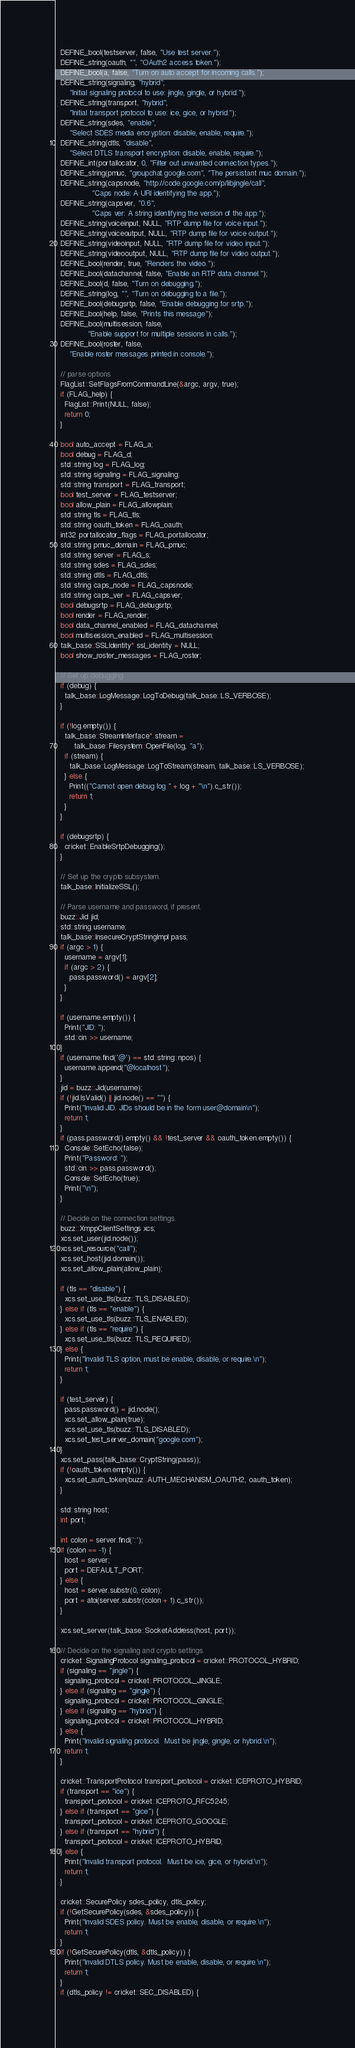<code> <loc_0><loc_0><loc_500><loc_500><_C++_>  DEFINE_bool(testserver, false, "Use test server.");
  DEFINE_string(oauth, "", "OAuth2 access token.");
  DEFINE_bool(a, false, "Turn on auto accept for incoming calls.");
  DEFINE_string(signaling, "hybrid",
      "Initial signaling protocol to use: jingle, gingle, or hybrid.");
  DEFINE_string(transport, "hybrid",
      "Initial transport protocol to use: ice, gice, or hybrid.");
  DEFINE_string(sdes, "enable",
      "Select SDES media encryption: disable, enable, require.");
  DEFINE_string(dtls, "disable",
      "Select DTLS transport encryption: disable, enable, require.");
  DEFINE_int(portallocator, 0, "Filter out unwanted connection types.");
  DEFINE_string(pmuc, "groupchat.google.com", "The persistant muc domain.");
  DEFINE_string(capsnode, "http://code.google.com/p/libjingle/call",
                "Caps node: A URI identifying the app.");
  DEFINE_string(capsver, "0.6",
                "Caps ver: A string identifying the version of the app.");
  DEFINE_string(voiceinput, NULL, "RTP dump file for voice input.");
  DEFINE_string(voiceoutput, NULL, "RTP dump file for voice output.");
  DEFINE_string(videoinput, NULL, "RTP dump file for video input.");
  DEFINE_string(videooutput, NULL, "RTP dump file for video output.");
  DEFINE_bool(render, true, "Renders the video.");
  DEFINE_bool(datachannel, false, "Enable an RTP data channel.");
  DEFINE_bool(d, false, "Turn on debugging.");
  DEFINE_string(log, "", "Turn on debugging to a file.");
  DEFINE_bool(debugsrtp, false, "Enable debugging for srtp.");
  DEFINE_bool(help, false, "Prints this message");
  DEFINE_bool(multisession, false,
              "Enable support for multiple sessions in calls.");
  DEFINE_bool(roster, false,
      "Enable roster messages printed in console.");

  // parse options
  FlagList::SetFlagsFromCommandLine(&argc, argv, true);
  if (FLAG_help) {
    FlagList::Print(NULL, false);
    return 0;
  }

  bool auto_accept = FLAG_a;
  bool debug = FLAG_d;
  std::string log = FLAG_log;
  std::string signaling = FLAG_signaling;
  std::string transport = FLAG_transport;
  bool test_server = FLAG_testserver;
  bool allow_plain = FLAG_allowplain;
  std::string tls = FLAG_tls;
  std::string oauth_token = FLAG_oauth;
  int32 portallocator_flags = FLAG_portallocator;
  std::string pmuc_domain = FLAG_pmuc;
  std::string server = FLAG_s;
  std::string sdes = FLAG_sdes;
  std::string dtls = FLAG_dtls;
  std::string caps_node = FLAG_capsnode;
  std::string caps_ver = FLAG_capsver;
  bool debugsrtp = FLAG_debugsrtp;
  bool render = FLAG_render;
  bool data_channel_enabled = FLAG_datachannel;
  bool multisession_enabled = FLAG_multisession;
  talk_base::SSLIdentity* ssl_identity = NULL;
  bool show_roster_messages = FLAG_roster;

  // Set up debugging.
  if (debug) {
    talk_base::LogMessage::LogToDebug(talk_base::LS_VERBOSE);
  }

  if (!log.empty()) {
    talk_base::StreamInterface* stream =
        talk_base::Filesystem::OpenFile(log, "a");
    if (stream) {
      talk_base::LogMessage::LogToStream(stream, talk_base::LS_VERBOSE);
    } else {
      Print(("Cannot open debug log " + log + "\n").c_str());
      return 1;
    }
  }

  if (debugsrtp) {
    cricket::EnableSrtpDebugging();
  }

  // Set up the crypto subsystem.
  talk_base::InitializeSSL();

  // Parse username and password, if present.
  buzz::Jid jid;
  std::string username;
  talk_base::InsecureCryptStringImpl pass;
  if (argc > 1) {
    username = argv[1];
    if (argc > 2) {
      pass.password() = argv[2];
    }
  }

  if (username.empty()) {
    Print("JID: ");
    std::cin >> username;
  }
  if (username.find('@') == std::string::npos) {
    username.append("@localhost");
  }
  jid = buzz::Jid(username);
  if (!jid.IsValid() || jid.node() == "") {
    Print("Invalid JID. JIDs should be in the form user@domain\n");
    return 1;
  }
  if (pass.password().empty() && !test_server && oauth_token.empty()) {
    Console::SetEcho(false);
    Print("Password: ");
    std::cin >> pass.password();
    Console::SetEcho(true);
    Print("\n");
  }

  // Decide on the connection settings.
  buzz::XmppClientSettings xcs;
  xcs.set_user(jid.node());
  xcs.set_resource("call");
  xcs.set_host(jid.domain());
  xcs.set_allow_plain(allow_plain);

  if (tls == "disable") {
    xcs.set_use_tls(buzz::TLS_DISABLED);
  } else if (tls == "enable") {
    xcs.set_use_tls(buzz::TLS_ENABLED);
  } else if (tls == "require") {
    xcs.set_use_tls(buzz::TLS_REQUIRED);
  } else {
    Print("Invalid TLS option, must be enable, disable, or require.\n");
    return 1;
  }

  if (test_server) {
    pass.password() = jid.node();
    xcs.set_allow_plain(true);
    xcs.set_use_tls(buzz::TLS_DISABLED);
    xcs.set_test_server_domain("google.com");
  }
  xcs.set_pass(talk_base::CryptString(pass));
  if (!oauth_token.empty()) {
    xcs.set_auth_token(buzz::AUTH_MECHANISM_OAUTH2, oauth_token);
  }

  std::string host;
  int port;

  int colon = server.find(':');
  if (colon == -1) {
    host = server;
    port = DEFAULT_PORT;
  } else {
    host = server.substr(0, colon);
    port = atoi(server.substr(colon + 1).c_str());
  }

  xcs.set_server(talk_base::SocketAddress(host, port));

  // Decide on the signaling and crypto settings.
  cricket::SignalingProtocol signaling_protocol = cricket::PROTOCOL_HYBRID;
  if (signaling == "jingle") {
    signaling_protocol = cricket::PROTOCOL_JINGLE;
  } else if (signaling == "gingle") {
    signaling_protocol = cricket::PROTOCOL_GINGLE;
  } else if (signaling == "hybrid") {
    signaling_protocol = cricket::PROTOCOL_HYBRID;
  } else {
    Print("Invalid signaling protocol.  Must be jingle, gingle, or hybrid.\n");
    return 1;
  }

  cricket::TransportProtocol transport_protocol = cricket::ICEPROTO_HYBRID;
  if (transport == "ice") {
    transport_protocol = cricket::ICEPROTO_RFC5245;
  } else if (transport == "gice") {
    transport_protocol = cricket::ICEPROTO_GOOGLE;
  } else if (transport == "hybrid") {
    transport_protocol = cricket::ICEPROTO_HYBRID;
  } else {
    Print("Invalid transport protocol.  Must be ice, gice, or hybrid.\n");
    return 1;
  }

  cricket::SecurePolicy sdes_policy, dtls_policy;
  if (!GetSecurePolicy(sdes, &sdes_policy)) {
    Print("Invalid SDES policy. Must be enable, disable, or require.\n");
    return 1;
  }
  if (!GetSecurePolicy(dtls, &dtls_policy)) {
    Print("Invalid DTLS policy. Must be enable, disable, or require.\n");
    return 1;
  }
  if (dtls_policy != cricket::SEC_DISABLED) {</code> 